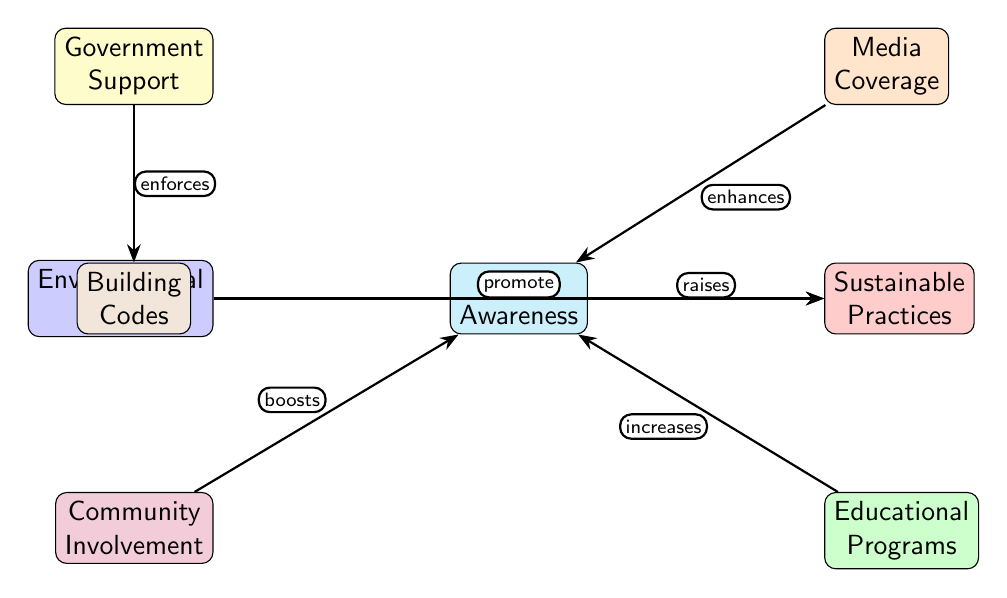What is the central concept represented in this diagram? The central concept in the diagram is "Public Awareness", which is the node located at the center. It serves as the central influence on other elements in the diagram.
Answer: Public Awareness How many nodes are there in the diagram? The diagram includes a total of 8 nodes, which can be counted by identifying each distinct labeled box within the illustration.
Answer: 8 What is the relationship between Media Coverage and Public Awareness? Media Coverage "enhances" Public Awareness, which indicates a positive influence between these two nodes as represented by the directed edge in the diagram.
Answer: enhances Which node directly influences Building Codes? Government Support directly influences Building Codes, as indicated by the direct edge labeled "enforces" from Government Support to Building Codes.
Answer: Government Support Which element is promoted by Environmental Groups? Environmental Groups promote Sustainable Practices, according to the directed edge connecting these two nodes, which indicates a supportive relationship.
Answer: Sustainable Practices What type of involvement boosts Public Awareness? Community Involvement boosts Public Awareness, as shown by the directed edge from Community Involvement to Public Awareness that indicates a positive influence on raising awareness.
Answer: Community Involvement How many edges are connected to the Public Awareness node? The Public Awareness node has 5 edges connected to it, representing influences from Media Coverage, Educational Programs, Community Involvement, and indirectly related to Sustainable Practices and Building Codes.
Answer: 5 What is the connection between Educational Programs and Public Awareness? Educational Programs "increases" Public Awareness, illustrating that educational initiatives contribute positively to the awareness among the public regarding sustainable practices.
Answer: increases Which factors enhance the perception of Sustainable Practices? Public Awareness, driven by Media Coverage and Educational Programs, enhances the perception of Sustainable Practices, indicating a network of supporting influences leading to sustainable outcomes.
Answer: Public Awareness, Media Coverage, Educational Programs 